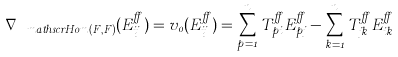Convert formula to latex. <formula><loc_0><loc_0><loc_500><loc_500>\nabla _ { \ m a t h s c r { H } o m ( F , F ) } ( E _ { i j } ^ { \alpha } ) = v _ { 0 } ( E _ { i j } ^ { \alpha } ) = \sum _ { p = 1 } ^ { n } T _ { p i } ^ { \alpha } E _ { p j } ^ { \alpha } - \sum _ { k = 1 } ^ { n } T _ { j k } ^ { \alpha } E _ { i k } ^ { \alpha }</formula> 